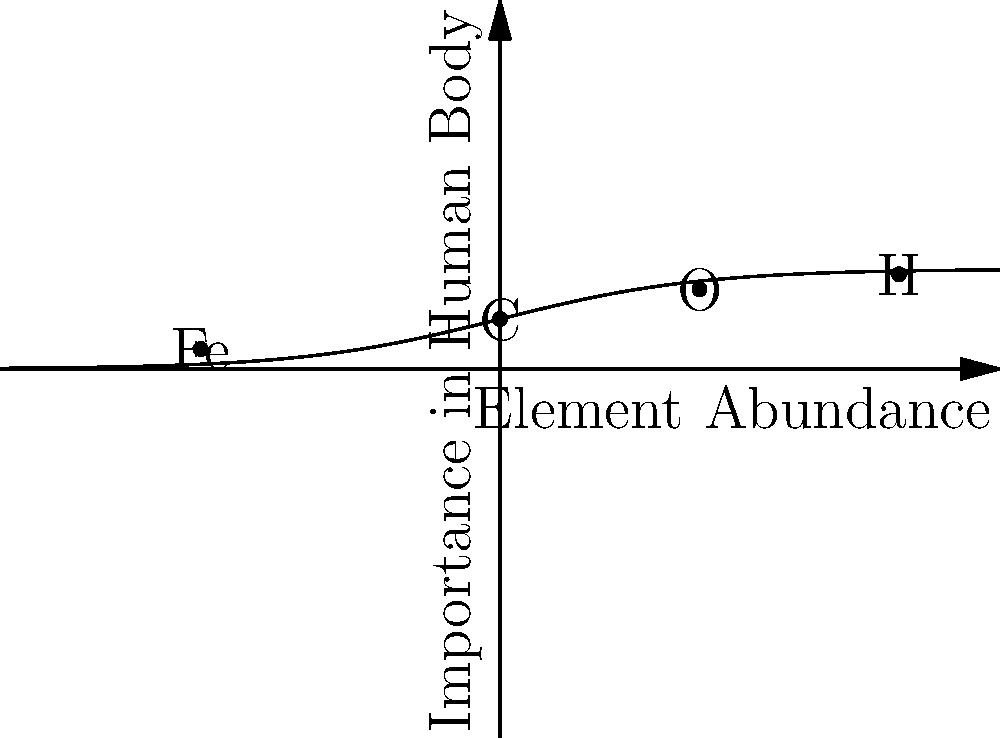The graph shows the relationship between the abundance of elements formed in stars and their importance in human body chemistry. Which element, crucial for oxygen transport in the blood and produced through stellar nucleosynthesis, is represented by the point (-3, 0.2)? To answer this question, we need to follow these steps:

1. Understand stellar nucleosynthesis:
   - Stars produce elements through nuclear fusion reactions.
   - Lighter elements (H, He) are formed in early stages of stellar evolution.
   - Heavier elements are produced in later stages and during supernova explosions.

2. Identify important elements in human body chemistry:
   - Hydrogen (H): Most abundant, crucial for water and organic molecules.
   - Carbon (C): Basis of organic chemistry, essential for all known life.
   - Oxygen (O): Vital for respiration and many biological processes.
   - Iron (Fe): Essential for oxygen transport in hemoglobin.

3. Analyze the graph:
   - X-axis represents element abundance (decreasing from right to left).
   - Y-axis represents importance in human body (increasing from bottom to top).
   - Four points are labeled: H, O, C, and Fe.

4. Locate the point (-3, 0.2):
   - This point is labeled "Fe" on the graph.

5. Connect iron's properties to the question:
   - Iron is crucial for oxygen transport in the blood as a component of hemoglobin.
   - Iron is produced through stellar nucleosynthesis in massive stars and dispersed by supernovae.

Therefore, the element represented by the point (-3, 0.2) is iron (Fe).
Answer: Iron (Fe) 